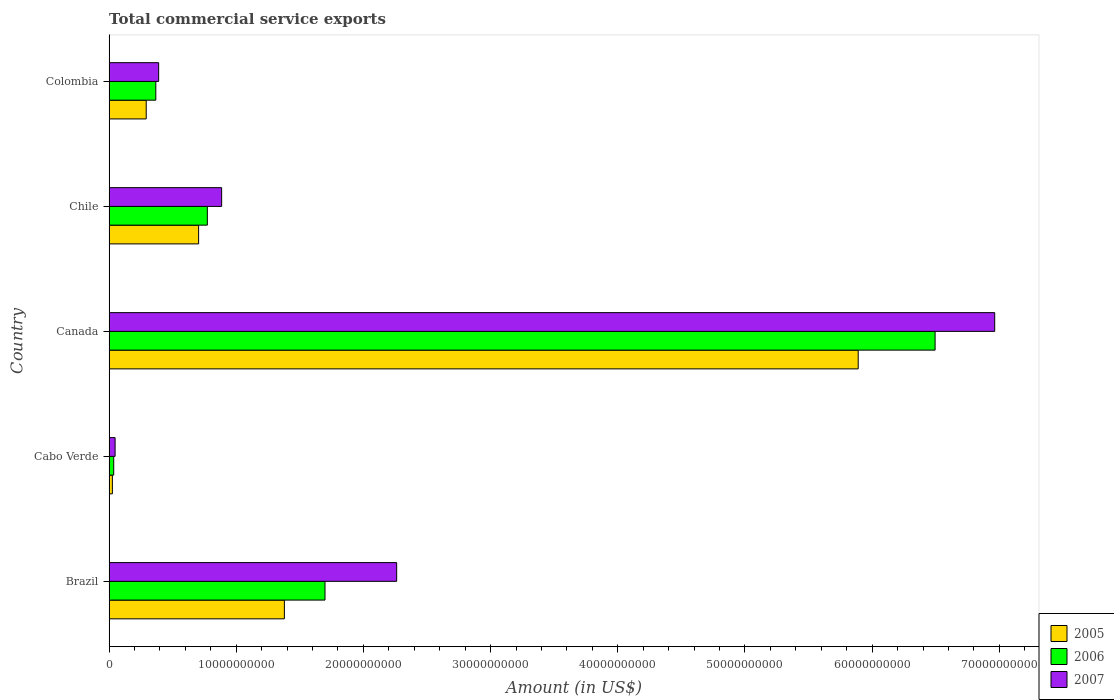How many different coloured bars are there?
Ensure brevity in your answer.  3. How many groups of bars are there?
Your answer should be very brief. 5. Are the number of bars per tick equal to the number of legend labels?
Your response must be concise. Yes. Are the number of bars on each tick of the Y-axis equal?
Give a very brief answer. Yes. How many bars are there on the 2nd tick from the top?
Offer a terse response. 3. What is the label of the 4th group of bars from the top?
Your response must be concise. Cabo Verde. What is the total commercial service exports in 2006 in Colombia?
Your response must be concise. 3.68e+09. Across all countries, what is the maximum total commercial service exports in 2005?
Your answer should be compact. 5.89e+1. Across all countries, what is the minimum total commercial service exports in 2006?
Make the answer very short. 3.66e+08. In which country was the total commercial service exports in 2006 maximum?
Offer a terse response. Canada. In which country was the total commercial service exports in 2005 minimum?
Offer a terse response. Cabo Verde. What is the total total commercial service exports in 2005 in the graph?
Your answer should be very brief. 8.29e+1. What is the difference between the total commercial service exports in 2006 in Brazil and that in Colombia?
Provide a short and direct response. 1.33e+1. What is the difference between the total commercial service exports in 2006 in Canada and the total commercial service exports in 2005 in Chile?
Offer a terse response. 5.79e+1. What is the average total commercial service exports in 2006 per country?
Provide a short and direct response. 1.87e+1. What is the difference between the total commercial service exports in 2006 and total commercial service exports in 2007 in Cabo Verde?
Offer a terse response. -1.08e+08. In how many countries, is the total commercial service exports in 2006 greater than 40000000000 US$?
Give a very brief answer. 1. What is the ratio of the total commercial service exports in 2005 in Cabo Verde to that in Chile?
Your answer should be very brief. 0.04. Is the total commercial service exports in 2007 in Canada less than that in Colombia?
Make the answer very short. No. What is the difference between the highest and the second highest total commercial service exports in 2007?
Offer a terse response. 4.70e+1. What is the difference between the highest and the lowest total commercial service exports in 2006?
Your answer should be compact. 6.46e+1. Is the sum of the total commercial service exports in 2006 in Cabo Verde and Canada greater than the maximum total commercial service exports in 2005 across all countries?
Ensure brevity in your answer.  Yes. Is it the case that in every country, the sum of the total commercial service exports in 2005 and total commercial service exports in 2007 is greater than the total commercial service exports in 2006?
Your response must be concise. Yes. What is the difference between two consecutive major ticks on the X-axis?
Offer a terse response. 1.00e+1. Are the values on the major ticks of X-axis written in scientific E-notation?
Your answer should be compact. No. Does the graph contain any zero values?
Offer a terse response. No. How are the legend labels stacked?
Provide a succinct answer. Vertical. What is the title of the graph?
Ensure brevity in your answer.  Total commercial service exports. What is the Amount (in US$) in 2005 in Brazil?
Your response must be concise. 1.38e+1. What is the Amount (in US$) in 2006 in Brazil?
Your answer should be very brief. 1.70e+1. What is the Amount (in US$) of 2007 in Brazil?
Offer a terse response. 2.26e+1. What is the Amount (in US$) in 2005 in Cabo Verde?
Offer a very short reply. 2.60e+08. What is the Amount (in US$) of 2006 in Cabo Verde?
Provide a short and direct response. 3.66e+08. What is the Amount (in US$) in 2007 in Cabo Verde?
Offer a terse response. 4.74e+08. What is the Amount (in US$) in 2005 in Canada?
Your answer should be very brief. 5.89e+1. What is the Amount (in US$) in 2006 in Canada?
Your answer should be compact. 6.50e+1. What is the Amount (in US$) of 2007 in Canada?
Your answer should be compact. 6.96e+1. What is the Amount (in US$) of 2005 in Chile?
Give a very brief answer. 7.04e+09. What is the Amount (in US$) in 2006 in Chile?
Keep it short and to the point. 7.73e+09. What is the Amount (in US$) of 2007 in Chile?
Your response must be concise. 8.85e+09. What is the Amount (in US$) in 2005 in Colombia?
Your response must be concise. 2.92e+09. What is the Amount (in US$) in 2006 in Colombia?
Your response must be concise. 3.68e+09. What is the Amount (in US$) of 2007 in Colombia?
Ensure brevity in your answer.  3.90e+09. Across all countries, what is the maximum Amount (in US$) in 2005?
Offer a terse response. 5.89e+1. Across all countries, what is the maximum Amount (in US$) in 2006?
Offer a very short reply. 6.50e+1. Across all countries, what is the maximum Amount (in US$) of 2007?
Your answer should be compact. 6.96e+1. Across all countries, what is the minimum Amount (in US$) in 2005?
Make the answer very short. 2.60e+08. Across all countries, what is the minimum Amount (in US$) in 2006?
Provide a succinct answer. 3.66e+08. Across all countries, what is the minimum Amount (in US$) of 2007?
Ensure brevity in your answer.  4.74e+08. What is the total Amount (in US$) of 2005 in the graph?
Offer a terse response. 8.29e+1. What is the total Amount (in US$) of 2006 in the graph?
Provide a short and direct response. 9.37e+1. What is the total Amount (in US$) in 2007 in the graph?
Ensure brevity in your answer.  1.05e+11. What is the difference between the Amount (in US$) of 2005 in Brazil and that in Cabo Verde?
Provide a short and direct response. 1.35e+1. What is the difference between the Amount (in US$) of 2006 in Brazil and that in Cabo Verde?
Provide a short and direct response. 1.66e+1. What is the difference between the Amount (in US$) of 2007 in Brazil and that in Cabo Verde?
Your response must be concise. 2.21e+1. What is the difference between the Amount (in US$) in 2005 in Brazil and that in Canada?
Offer a terse response. -4.51e+1. What is the difference between the Amount (in US$) of 2006 in Brazil and that in Canada?
Offer a terse response. -4.80e+1. What is the difference between the Amount (in US$) of 2007 in Brazil and that in Canada?
Provide a short and direct response. -4.70e+1. What is the difference between the Amount (in US$) in 2005 in Brazil and that in Chile?
Provide a succinct answer. 6.74e+09. What is the difference between the Amount (in US$) of 2006 in Brazil and that in Chile?
Your answer should be compact. 9.25e+09. What is the difference between the Amount (in US$) of 2007 in Brazil and that in Chile?
Make the answer very short. 1.38e+1. What is the difference between the Amount (in US$) of 2005 in Brazil and that in Colombia?
Give a very brief answer. 1.09e+1. What is the difference between the Amount (in US$) of 2006 in Brazil and that in Colombia?
Offer a very short reply. 1.33e+1. What is the difference between the Amount (in US$) of 2007 in Brazil and that in Colombia?
Keep it short and to the point. 1.87e+1. What is the difference between the Amount (in US$) of 2005 in Cabo Verde and that in Canada?
Make the answer very short. -5.86e+1. What is the difference between the Amount (in US$) in 2006 in Cabo Verde and that in Canada?
Provide a short and direct response. -6.46e+1. What is the difference between the Amount (in US$) in 2007 in Cabo Verde and that in Canada?
Offer a very short reply. -6.92e+1. What is the difference between the Amount (in US$) in 2005 in Cabo Verde and that in Chile?
Provide a succinct answer. -6.78e+09. What is the difference between the Amount (in US$) of 2006 in Cabo Verde and that in Chile?
Keep it short and to the point. -7.36e+09. What is the difference between the Amount (in US$) in 2007 in Cabo Verde and that in Chile?
Make the answer very short. -8.38e+09. What is the difference between the Amount (in US$) in 2005 in Cabo Verde and that in Colombia?
Provide a succinct answer. -2.66e+09. What is the difference between the Amount (in US$) in 2006 in Cabo Verde and that in Colombia?
Provide a short and direct response. -3.31e+09. What is the difference between the Amount (in US$) of 2007 in Cabo Verde and that in Colombia?
Offer a very short reply. -3.42e+09. What is the difference between the Amount (in US$) of 2005 in Canada and that in Chile?
Your answer should be compact. 5.19e+1. What is the difference between the Amount (in US$) in 2006 in Canada and that in Chile?
Offer a very short reply. 5.72e+1. What is the difference between the Amount (in US$) in 2007 in Canada and that in Chile?
Give a very brief answer. 6.08e+1. What is the difference between the Amount (in US$) in 2005 in Canada and that in Colombia?
Provide a succinct answer. 5.60e+1. What is the difference between the Amount (in US$) in 2006 in Canada and that in Colombia?
Provide a succinct answer. 6.13e+1. What is the difference between the Amount (in US$) of 2007 in Canada and that in Colombia?
Offer a terse response. 6.57e+1. What is the difference between the Amount (in US$) in 2005 in Chile and that in Colombia?
Make the answer very short. 4.12e+09. What is the difference between the Amount (in US$) in 2006 in Chile and that in Colombia?
Give a very brief answer. 4.05e+09. What is the difference between the Amount (in US$) of 2007 in Chile and that in Colombia?
Offer a very short reply. 4.95e+09. What is the difference between the Amount (in US$) in 2005 in Brazil and the Amount (in US$) in 2006 in Cabo Verde?
Your answer should be compact. 1.34e+1. What is the difference between the Amount (in US$) in 2005 in Brazil and the Amount (in US$) in 2007 in Cabo Verde?
Keep it short and to the point. 1.33e+1. What is the difference between the Amount (in US$) in 2006 in Brazil and the Amount (in US$) in 2007 in Cabo Verde?
Offer a terse response. 1.65e+1. What is the difference between the Amount (in US$) in 2005 in Brazil and the Amount (in US$) in 2006 in Canada?
Your response must be concise. -5.12e+1. What is the difference between the Amount (in US$) in 2005 in Brazil and the Amount (in US$) in 2007 in Canada?
Your answer should be very brief. -5.59e+1. What is the difference between the Amount (in US$) of 2006 in Brazil and the Amount (in US$) of 2007 in Canada?
Offer a very short reply. -5.27e+1. What is the difference between the Amount (in US$) of 2005 in Brazil and the Amount (in US$) of 2006 in Chile?
Provide a succinct answer. 6.06e+09. What is the difference between the Amount (in US$) in 2005 in Brazil and the Amount (in US$) in 2007 in Chile?
Your response must be concise. 4.93e+09. What is the difference between the Amount (in US$) of 2006 in Brazil and the Amount (in US$) of 2007 in Chile?
Your answer should be very brief. 8.13e+09. What is the difference between the Amount (in US$) in 2005 in Brazil and the Amount (in US$) in 2006 in Colombia?
Ensure brevity in your answer.  1.01e+1. What is the difference between the Amount (in US$) of 2005 in Brazil and the Amount (in US$) of 2007 in Colombia?
Your answer should be very brief. 9.89e+09. What is the difference between the Amount (in US$) in 2006 in Brazil and the Amount (in US$) in 2007 in Colombia?
Your answer should be very brief. 1.31e+1. What is the difference between the Amount (in US$) in 2005 in Cabo Verde and the Amount (in US$) in 2006 in Canada?
Provide a short and direct response. -6.47e+1. What is the difference between the Amount (in US$) in 2005 in Cabo Verde and the Amount (in US$) in 2007 in Canada?
Provide a short and direct response. -6.94e+1. What is the difference between the Amount (in US$) of 2006 in Cabo Verde and the Amount (in US$) of 2007 in Canada?
Provide a succinct answer. -6.93e+1. What is the difference between the Amount (in US$) in 2005 in Cabo Verde and the Amount (in US$) in 2006 in Chile?
Ensure brevity in your answer.  -7.47e+09. What is the difference between the Amount (in US$) of 2005 in Cabo Verde and the Amount (in US$) of 2007 in Chile?
Ensure brevity in your answer.  -8.59e+09. What is the difference between the Amount (in US$) of 2006 in Cabo Verde and the Amount (in US$) of 2007 in Chile?
Your answer should be compact. -8.49e+09. What is the difference between the Amount (in US$) in 2005 in Cabo Verde and the Amount (in US$) in 2006 in Colombia?
Provide a short and direct response. -3.41e+09. What is the difference between the Amount (in US$) of 2005 in Cabo Verde and the Amount (in US$) of 2007 in Colombia?
Make the answer very short. -3.64e+09. What is the difference between the Amount (in US$) of 2006 in Cabo Verde and the Amount (in US$) of 2007 in Colombia?
Make the answer very short. -3.53e+09. What is the difference between the Amount (in US$) in 2005 in Canada and the Amount (in US$) in 2006 in Chile?
Your answer should be compact. 5.12e+1. What is the difference between the Amount (in US$) in 2005 in Canada and the Amount (in US$) in 2007 in Chile?
Your answer should be very brief. 5.01e+1. What is the difference between the Amount (in US$) in 2006 in Canada and the Amount (in US$) in 2007 in Chile?
Provide a short and direct response. 5.61e+1. What is the difference between the Amount (in US$) of 2005 in Canada and the Amount (in US$) of 2006 in Colombia?
Offer a very short reply. 5.52e+1. What is the difference between the Amount (in US$) of 2005 in Canada and the Amount (in US$) of 2007 in Colombia?
Keep it short and to the point. 5.50e+1. What is the difference between the Amount (in US$) in 2006 in Canada and the Amount (in US$) in 2007 in Colombia?
Offer a very short reply. 6.11e+1. What is the difference between the Amount (in US$) in 2005 in Chile and the Amount (in US$) in 2006 in Colombia?
Offer a terse response. 3.37e+09. What is the difference between the Amount (in US$) of 2005 in Chile and the Amount (in US$) of 2007 in Colombia?
Your answer should be very brief. 3.14e+09. What is the difference between the Amount (in US$) of 2006 in Chile and the Amount (in US$) of 2007 in Colombia?
Offer a terse response. 3.83e+09. What is the average Amount (in US$) in 2005 per country?
Make the answer very short. 1.66e+1. What is the average Amount (in US$) of 2006 per country?
Give a very brief answer. 1.87e+1. What is the average Amount (in US$) in 2007 per country?
Keep it short and to the point. 2.11e+1. What is the difference between the Amount (in US$) of 2005 and Amount (in US$) of 2006 in Brazil?
Your response must be concise. -3.19e+09. What is the difference between the Amount (in US$) in 2005 and Amount (in US$) in 2007 in Brazil?
Give a very brief answer. -8.83e+09. What is the difference between the Amount (in US$) of 2006 and Amount (in US$) of 2007 in Brazil?
Provide a succinct answer. -5.64e+09. What is the difference between the Amount (in US$) in 2005 and Amount (in US$) in 2006 in Cabo Verde?
Provide a succinct answer. -1.05e+08. What is the difference between the Amount (in US$) of 2005 and Amount (in US$) of 2007 in Cabo Verde?
Make the answer very short. -2.13e+08. What is the difference between the Amount (in US$) of 2006 and Amount (in US$) of 2007 in Cabo Verde?
Make the answer very short. -1.08e+08. What is the difference between the Amount (in US$) of 2005 and Amount (in US$) of 2006 in Canada?
Offer a very short reply. -6.05e+09. What is the difference between the Amount (in US$) of 2005 and Amount (in US$) of 2007 in Canada?
Ensure brevity in your answer.  -1.07e+1. What is the difference between the Amount (in US$) of 2006 and Amount (in US$) of 2007 in Canada?
Give a very brief answer. -4.69e+09. What is the difference between the Amount (in US$) of 2005 and Amount (in US$) of 2006 in Chile?
Give a very brief answer. -6.87e+08. What is the difference between the Amount (in US$) of 2005 and Amount (in US$) of 2007 in Chile?
Give a very brief answer. -1.81e+09. What is the difference between the Amount (in US$) in 2006 and Amount (in US$) in 2007 in Chile?
Keep it short and to the point. -1.12e+09. What is the difference between the Amount (in US$) of 2005 and Amount (in US$) of 2006 in Colombia?
Your answer should be very brief. -7.54e+08. What is the difference between the Amount (in US$) in 2005 and Amount (in US$) in 2007 in Colombia?
Your answer should be very brief. -9.77e+08. What is the difference between the Amount (in US$) in 2006 and Amount (in US$) in 2007 in Colombia?
Offer a very short reply. -2.23e+08. What is the ratio of the Amount (in US$) in 2005 in Brazil to that in Cabo Verde?
Your response must be concise. 52.92. What is the ratio of the Amount (in US$) of 2006 in Brazil to that in Cabo Verde?
Give a very brief answer. 46.44. What is the ratio of the Amount (in US$) of 2007 in Brazil to that in Cabo Verde?
Keep it short and to the point. 47.74. What is the ratio of the Amount (in US$) of 2005 in Brazil to that in Canada?
Your answer should be very brief. 0.23. What is the ratio of the Amount (in US$) in 2006 in Brazil to that in Canada?
Offer a very short reply. 0.26. What is the ratio of the Amount (in US$) in 2007 in Brazil to that in Canada?
Offer a very short reply. 0.32. What is the ratio of the Amount (in US$) in 2005 in Brazil to that in Chile?
Give a very brief answer. 1.96. What is the ratio of the Amount (in US$) of 2006 in Brazil to that in Chile?
Keep it short and to the point. 2.2. What is the ratio of the Amount (in US$) of 2007 in Brazil to that in Chile?
Your answer should be compact. 2.55. What is the ratio of the Amount (in US$) of 2005 in Brazil to that in Colombia?
Give a very brief answer. 4.72. What is the ratio of the Amount (in US$) in 2006 in Brazil to that in Colombia?
Offer a terse response. 4.62. What is the ratio of the Amount (in US$) in 2007 in Brazil to that in Colombia?
Make the answer very short. 5.8. What is the ratio of the Amount (in US$) of 2005 in Cabo Verde to that in Canada?
Your response must be concise. 0. What is the ratio of the Amount (in US$) of 2006 in Cabo Verde to that in Canada?
Provide a succinct answer. 0.01. What is the ratio of the Amount (in US$) in 2007 in Cabo Verde to that in Canada?
Keep it short and to the point. 0.01. What is the ratio of the Amount (in US$) of 2005 in Cabo Verde to that in Chile?
Offer a terse response. 0.04. What is the ratio of the Amount (in US$) in 2006 in Cabo Verde to that in Chile?
Give a very brief answer. 0.05. What is the ratio of the Amount (in US$) in 2007 in Cabo Verde to that in Chile?
Keep it short and to the point. 0.05. What is the ratio of the Amount (in US$) of 2005 in Cabo Verde to that in Colombia?
Give a very brief answer. 0.09. What is the ratio of the Amount (in US$) in 2006 in Cabo Verde to that in Colombia?
Provide a short and direct response. 0.1. What is the ratio of the Amount (in US$) of 2007 in Cabo Verde to that in Colombia?
Your answer should be compact. 0.12. What is the ratio of the Amount (in US$) in 2005 in Canada to that in Chile?
Offer a very short reply. 8.37. What is the ratio of the Amount (in US$) of 2006 in Canada to that in Chile?
Your answer should be very brief. 8.4. What is the ratio of the Amount (in US$) of 2007 in Canada to that in Chile?
Keep it short and to the point. 7.87. What is the ratio of the Amount (in US$) in 2005 in Canada to that in Colombia?
Offer a terse response. 20.16. What is the ratio of the Amount (in US$) of 2006 in Canada to that in Colombia?
Your response must be concise. 17.67. What is the ratio of the Amount (in US$) of 2007 in Canada to that in Colombia?
Provide a short and direct response. 17.86. What is the ratio of the Amount (in US$) of 2005 in Chile to that in Colombia?
Give a very brief answer. 2.41. What is the ratio of the Amount (in US$) in 2006 in Chile to that in Colombia?
Offer a very short reply. 2.1. What is the ratio of the Amount (in US$) of 2007 in Chile to that in Colombia?
Give a very brief answer. 2.27. What is the difference between the highest and the second highest Amount (in US$) of 2005?
Provide a succinct answer. 4.51e+1. What is the difference between the highest and the second highest Amount (in US$) in 2006?
Make the answer very short. 4.80e+1. What is the difference between the highest and the second highest Amount (in US$) of 2007?
Your answer should be compact. 4.70e+1. What is the difference between the highest and the lowest Amount (in US$) in 2005?
Offer a very short reply. 5.86e+1. What is the difference between the highest and the lowest Amount (in US$) of 2006?
Your response must be concise. 6.46e+1. What is the difference between the highest and the lowest Amount (in US$) in 2007?
Your response must be concise. 6.92e+1. 